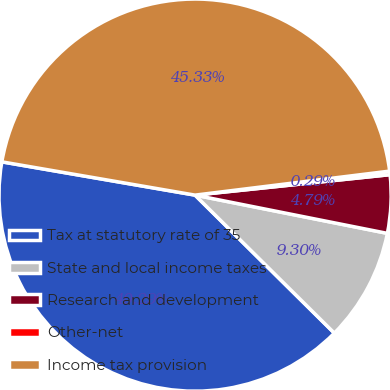<chart> <loc_0><loc_0><loc_500><loc_500><pie_chart><fcel>Tax at statutory rate of 35<fcel>State and local income taxes<fcel>Research and development<fcel>Other-net<fcel>Income tax provision<nl><fcel>40.29%<fcel>9.3%<fcel>4.79%<fcel>0.29%<fcel>45.33%<nl></chart> 